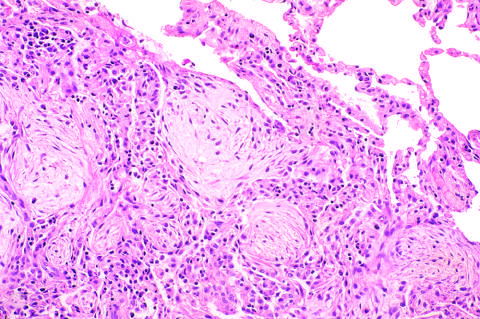how is advanced organizing pneumonia, featuring transformation of exudates to fibromyxoid masses infiltrate?
Answer the question using a single word or phrase. By macrophages and fibroblasts 